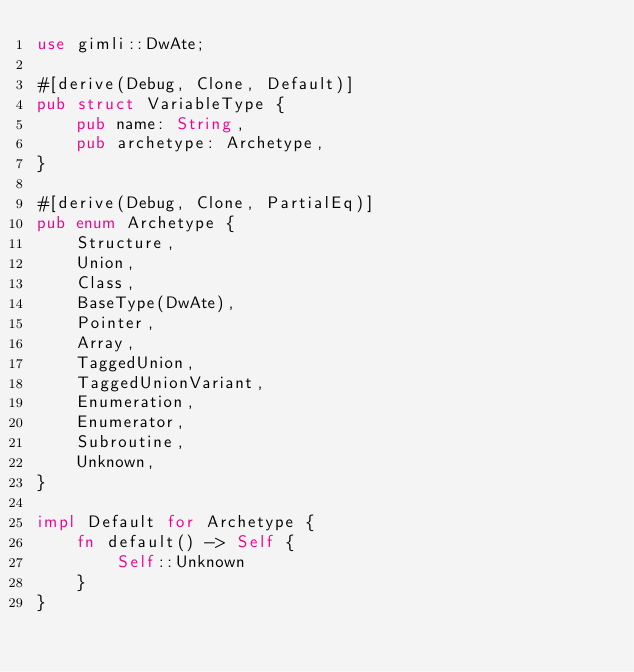Convert code to text. <code><loc_0><loc_0><loc_500><loc_500><_Rust_>use gimli::DwAte;

#[derive(Debug, Clone, Default)]
pub struct VariableType {
    pub name: String,
    pub archetype: Archetype,
}

#[derive(Debug, Clone, PartialEq)]
pub enum Archetype {
    Structure,
    Union,
    Class,
    BaseType(DwAte),
    Pointer,
    Array,
    TaggedUnion,
    TaggedUnionVariant,
    Enumeration,
    Enumerator,
    Subroutine,
    Unknown,
}

impl Default for Archetype {
    fn default() -> Self {
        Self::Unknown
    }
}
</code> 